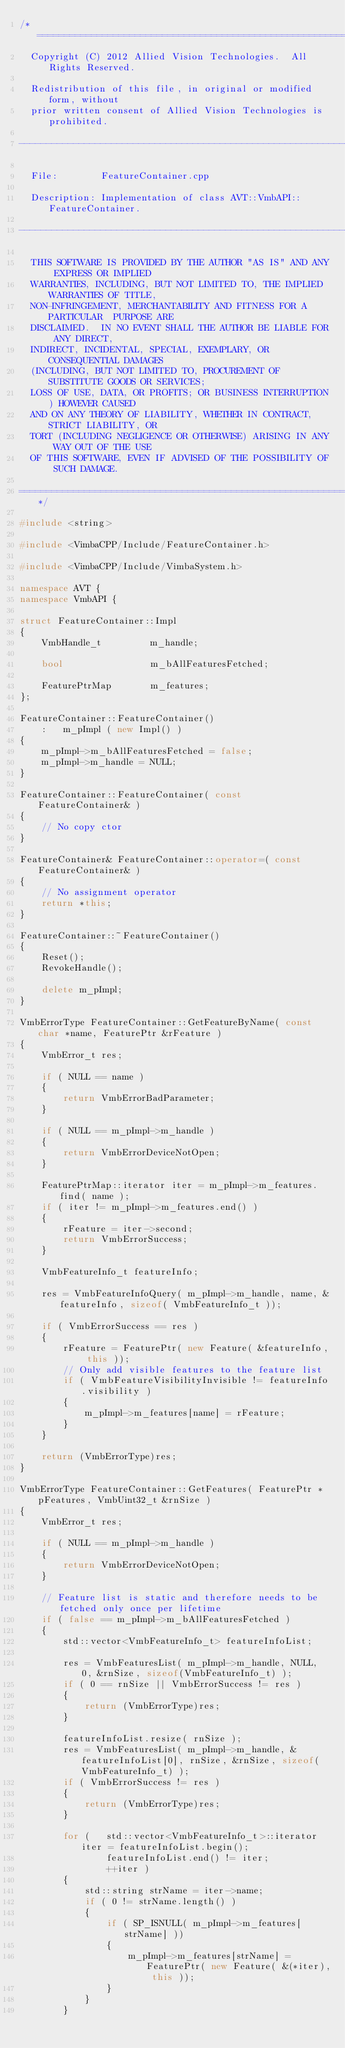Convert code to text. <code><loc_0><loc_0><loc_500><loc_500><_C++_>/*=============================================================================
  Copyright (C) 2012 Allied Vision Technologies.  All Rights Reserved.

  Redistribution of this file, in original or modified form, without
  prior written consent of Allied Vision Technologies is prohibited.

-------------------------------------------------------------------------------
 
  File:        FeatureContainer.cpp

  Description: Implementation of class AVT::VmbAPI::FeatureContainer.

-------------------------------------------------------------------------------

  THIS SOFTWARE IS PROVIDED BY THE AUTHOR "AS IS" AND ANY EXPRESS OR IMPLIED
  WARRANTIES, INCLUDING, BUT NOT LIMITED TO, THE IMPLIED WARRANTIES OF TITLE,
  NON-INFRINGEMENT, MERCHANTABILITY AND FITNESS FOR A PARTICULAR  PURPOSE ARE
  DISCLAIMED.  IN NO EVENT SHALL THE AUTHOR BE LIABLE FOR ANY DIRECT, 
  INDIRECT, INCIDENTAL, SPECIAL, EXEMPLARY, OR CONSEQUENTIAL DAMAGES 
  (INCLUDING, BUT NOT LIMITED TO, PROCUREMENT OF SUBSTITUTE GOODS OR SERVICES;
  LOSS OF USE, DATA, OR PROFITS; OR BUSINESS INTERRUPTION) HOWEVER CAUSED  
  AND ON ANY THEORY OF LIABILITY, WHETHER IN CONTRACT, STRICT LIABILITY, OR 
  TORT (INCLUDING NEGLIGENCE OR OTHERWISE) ARISING IN ANY WAY OUT OF THE USE 
  OF THIS SOFTWARE, EVEN IF ADVISED OF THE POSSIBILITY OF SUCH DAMAGE.

=============================================================================*/

#include <string>

#include <VimbaCPP/Include/FeatureContainer.h>

#include <VimbaCPP/Include/VimbaSystem.h>

namespace AVT {
namespace VmbAPI {

struct FeatureContainer::Impl
{
    VmbHandle_t         m_handle;

    bool                m_bAllFeaturesFetched;

    FeaturePtrMap       m_features;
};

FeatureContainer::FeatureContainer()
    :   m_pImpl ( new Impl() )
{
    m_pImpl->m_bAllFeaturesFetched = false;
    m_pImpl->m_handle = NULL;
}

FeatureContainer::FeatureContainer( const FeatureContainer& )
{
    // No copy ctor
}

FeatureContainer& FeatureContainer::operator=( const FeatureContainer& )
{
    // No assignment operator
    return *this;
}

FeatureContainer::~FeatureContainer()
{
    Reset();
    RevokeHandle();

    delete m_pImpl;
}

VmbErrorType FeatureContainer::GetFeatureByName( const char *name, FeaturePtr &rFeature )
{
    VmbError_t res;

    if ( NULL == name )
    {
        return VmbErrorBadParameter;
    }

    if ( NULL == m_pImpl->m_handle )
    {
        return VmbErrorDeviceNotOpen;
    }

    FeaturePtrMap::iterator iter = m_pImpl->m_features.find( name );
    if ( iter != m_pImpl->m_features.end() )
    {
        rFeature = iter->second;
        return VmbErrorSuccess;
    }

    VmbFeatureInfo_t featureInfo;
        
    res = VmbFeatureInfoQuery( m_pImpl->m_handle, name, &featureInfo, sizeof( VmbFeatureInfo_t ));

    if ( VmbErrorSuccess == res )
    {
        rFeature = FeaturePtr( new Feature( &featureInfo, this ));
        // Only add visible features to the feature list
        if ( VmbFeatureVisibilityInvisible != featureInfo.visibility )
        {
            m_pImpl->m_features[name] = rFeature;
        }
    }

    return (VmbErrorType)res;
}

VmbErrorType FeatureContainer::GetFeatures( FeaturePtr *pFeatures, VmbUint32_t &rnSize )
{
    VmbError_t res;

    if ( NULL == m_pImpl->m_handle )
    {
        return VmbErrorDeviceNotOpen;
    }

    // Feature list is static and therefore needs to be fetched only once per lifetime
    if ( false == m_pImpl->m_bAllFeaturesFetched )
    {
        std::vector<VmbFeatureInfo_t> featureInfoList;

        res = VmbFeaturesList( m_pImpl->m_handle, NULL, 0, &rnSize, sizeof(VmbFeatureInfo_t) );
        if ( 0 == rnSize || VmbErrorSuccess != res )
        {
            return (VmbErrorType)res;
        }

        featureInfoList.resize( rnSize );
        res = VmbFeaturesList( m_pImpl->m_handle, &featureInfoList[0], rnSize, &rnSize, sizeof(VmbFeatureInfo_t) );
        if ( VmbErrorSuccess != res )
        {
            return (VmbErrorType)res;
        }

        for (   std::vector<VmbFeatureInfo_t>::iterator iter = featureInfoList.begin();
                featureInfoList.end() != iter;
                ++iter )
        {
            std::string strName = iter->name;
            if ( 0 != strName.length() )
            {
                if ( SP_ISNULL( m_pImpl->m_features[strName] ))
                {
                    m_pImpl->m_features[strName] = FeaturePtr( new Feature( &(*iter), this ));
                }
            }
        }
</code> 